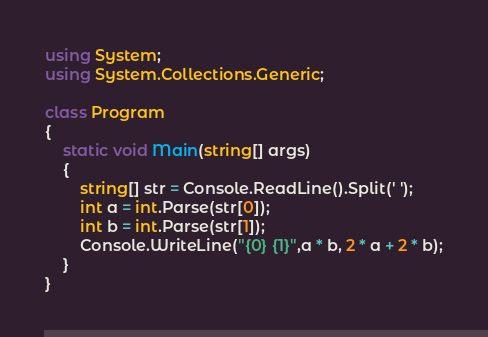Convert code to text. <code><loc_0><loc_0><loc_500><loc_500><_C#_>using System;
using System.Collections.Generic;

class Program
{
    static void Main(string[] args)
    {
        string[] str = Console.ReadLine().Split(' ');
        int a = int.Parse(str[0]);
        int b = int.Parse(str[1]);
        Console.WriteLine("{0} {1}",a * b, 2 * a + 2 * b);
    }
}</code> 